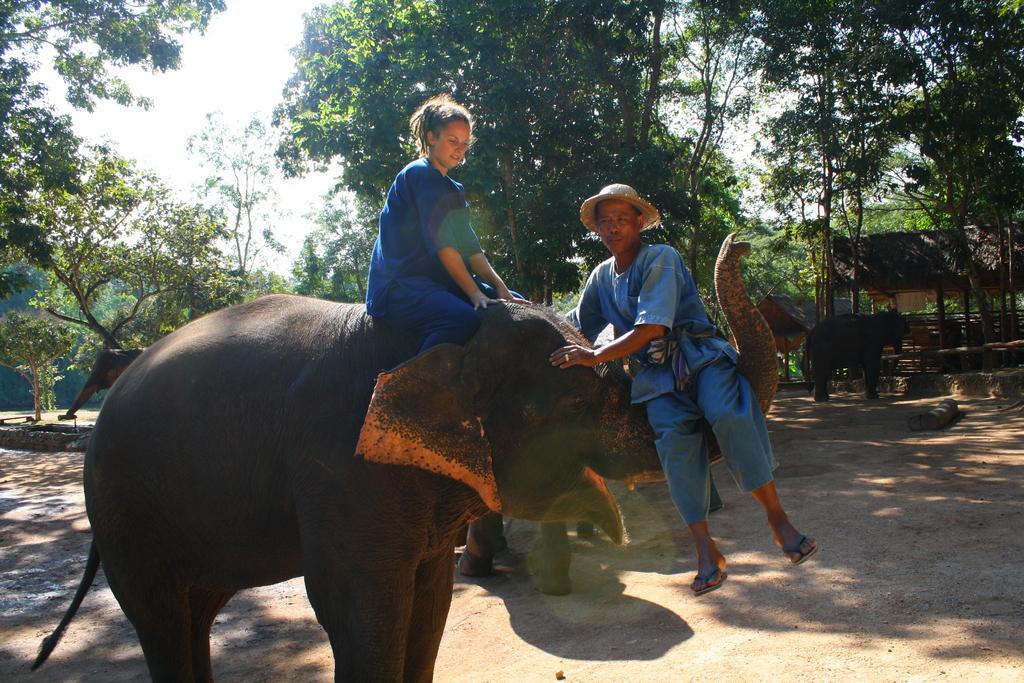Please provide a concise description of this image. This image consist of a elephant and two person. The man is sitting on a trunk of elephant. And woman is sitting on the elephant. In the background there are trees, huts and elephants. The persons are wearing blue dress. 